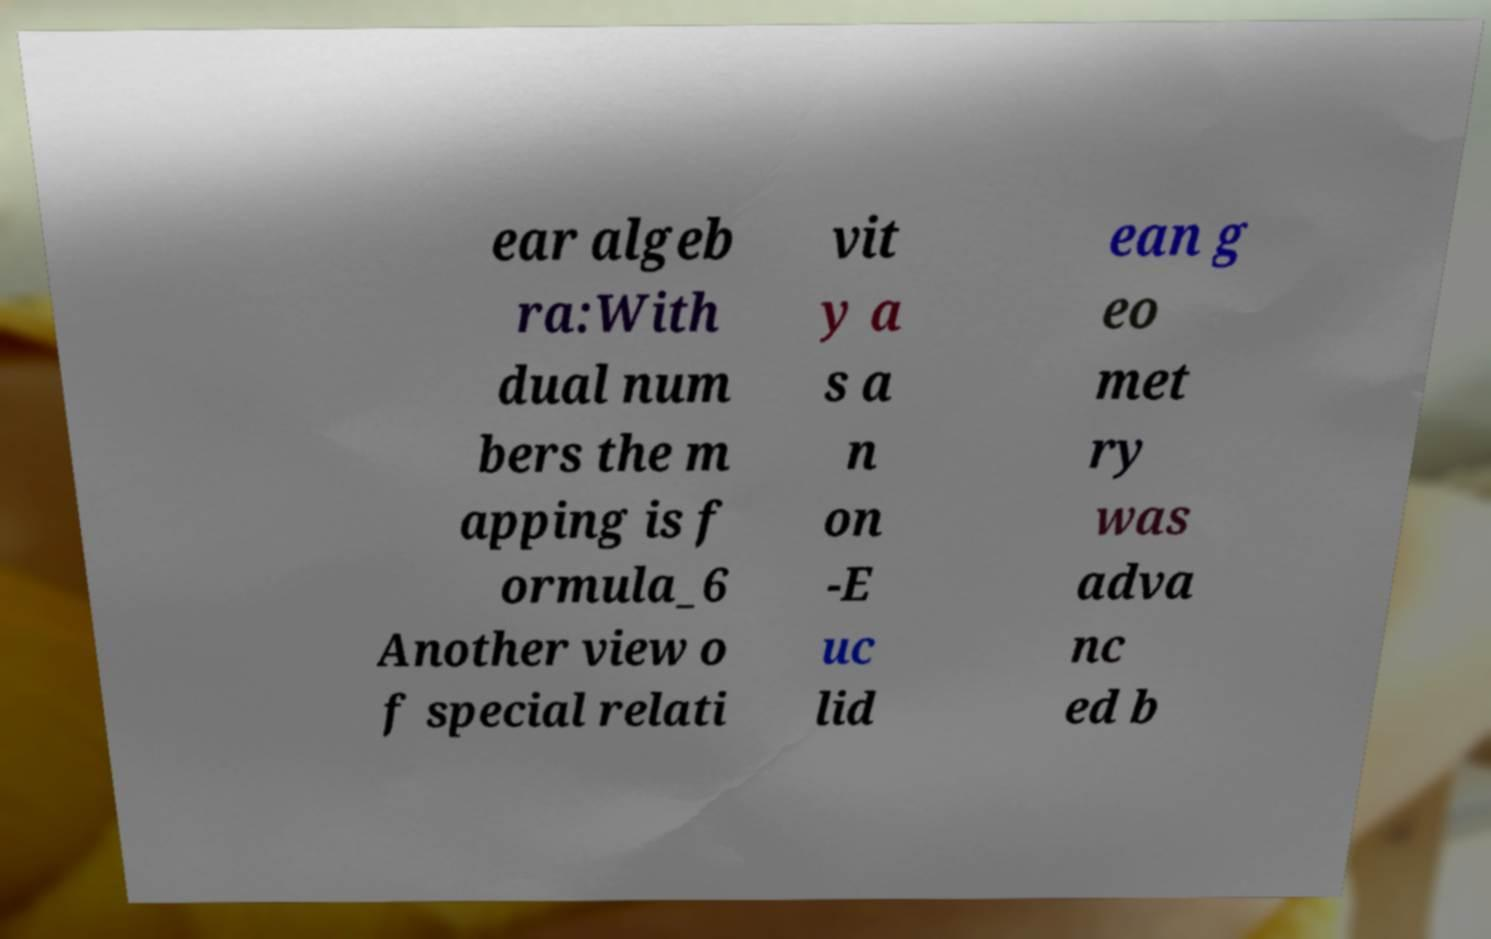Please read and relay the text visible in this image. What does it say? ear algeb ra:With dual num bers the m apping is f ormula_6 Another view o f special relati vit y a s a n on -E uc lid ean g eo met ry was adva nc ed b 